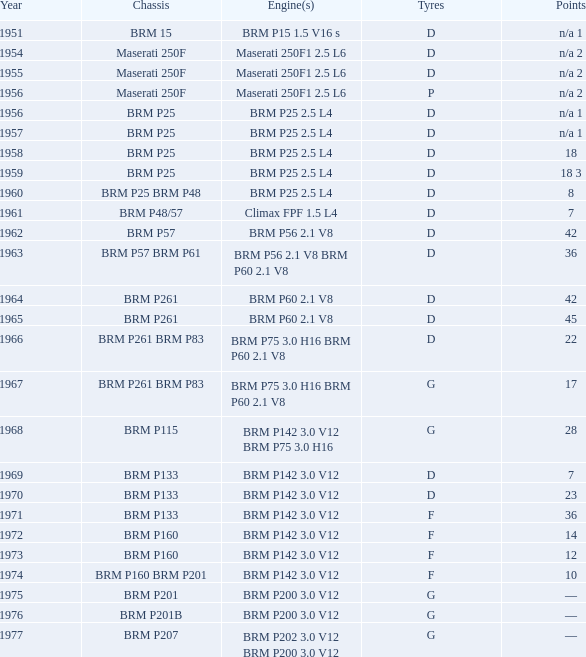Name the chassis of 1961 BRM P48/57. 